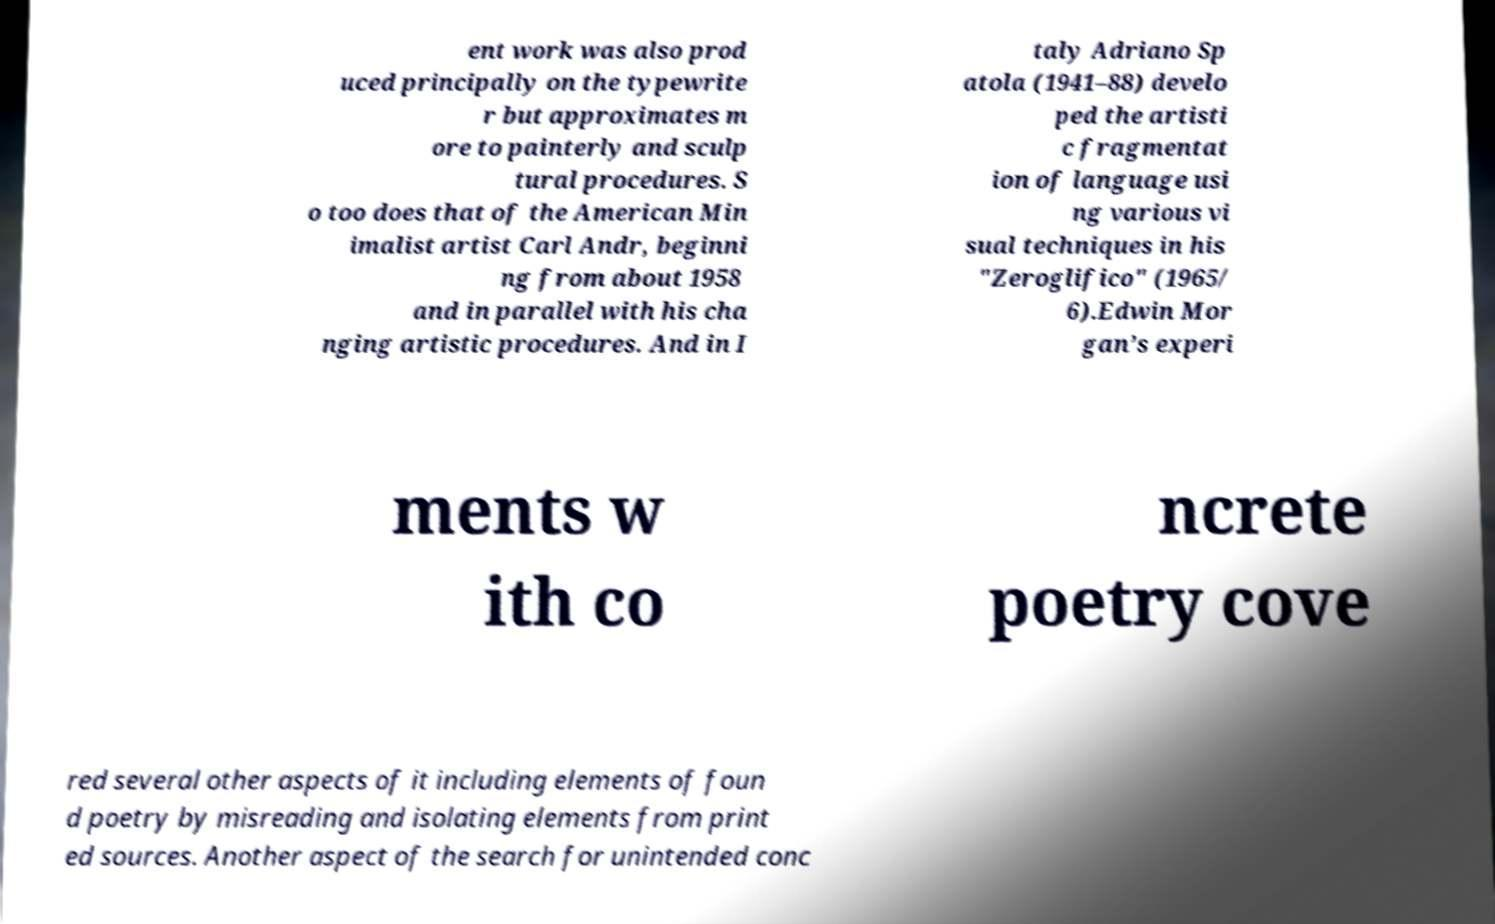Can you read and provide the text displayed in the image?This photo seems to have some interesting text. Can you extract and type it out for me? ent work was also prod uced principally on the typewrite r but approximates m ore to painterly and sculp tural procedures. S o too does that of the American Min imalist artist Carl Andr, beginni ng from about 1958 and in parallel with his cha nging artistic procedures. And in I taly Adriano Sp atola (1941–88) develo ped the artisti c fragmentat ion of language usi ng various vi sual techniques in his "Zeroglifico" (1965/ 6).Edwin Mor gan’s experi ments w ith co ncrete poetry cove red several other aspects of it including elements of foun d poetry by misreading and isolating elements from print ed sources. Another aspect of the search for unintended conc 